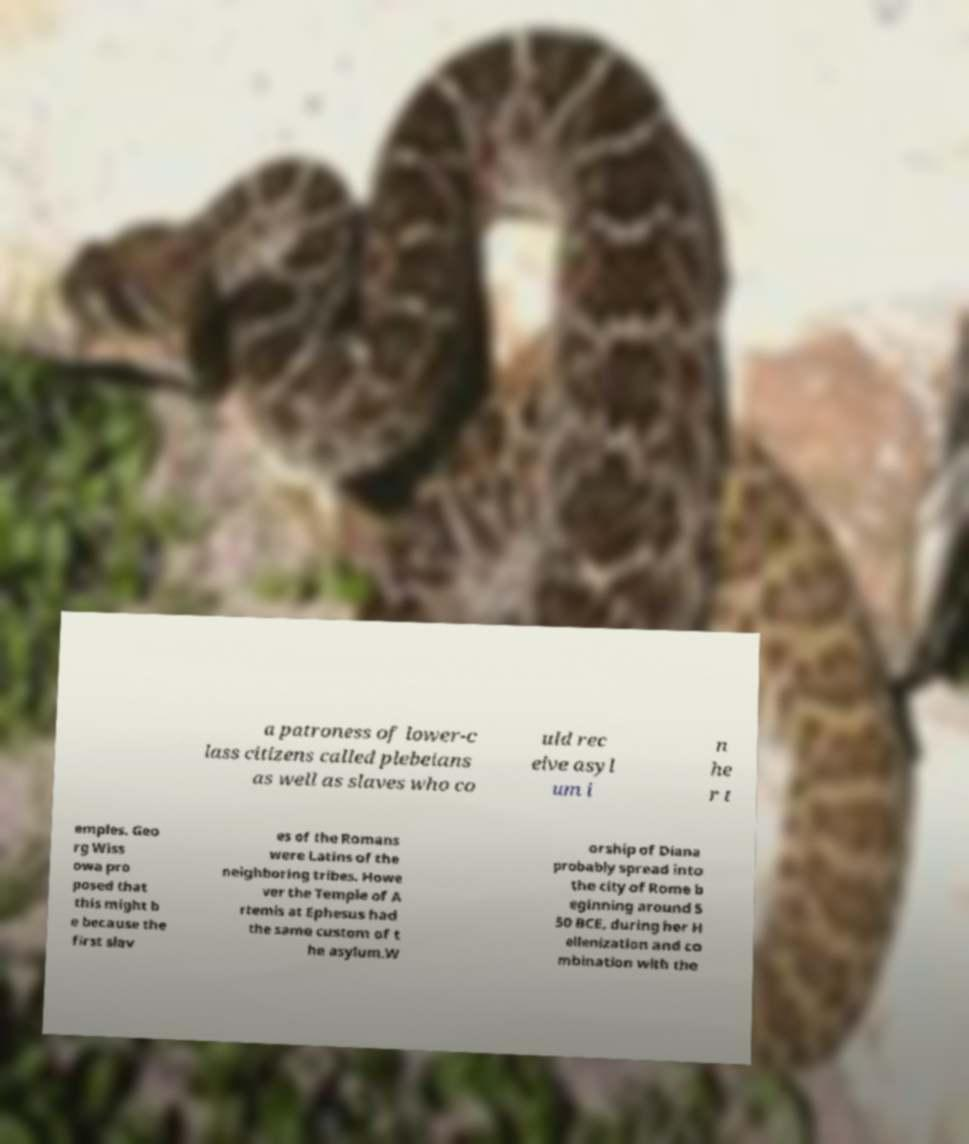Could you assist in decoding the text presented in this image and type it out clearly? a patroness of lower-c lass citizens called plebeians as well as slaves who co uld rec eive asyl um i n he r t emples. Geo rg Wiss owa pro posed that this might b e because the first slav es of the Romans were Latins of the neighboring tribes. Howe ver the Temple of A rtemis at Ephesus had the same custom of t he asylum.W orship of Diana probably spread into the city of Rome b eginning around 5 50 BCE, during her H ellenization and co mbination with the 